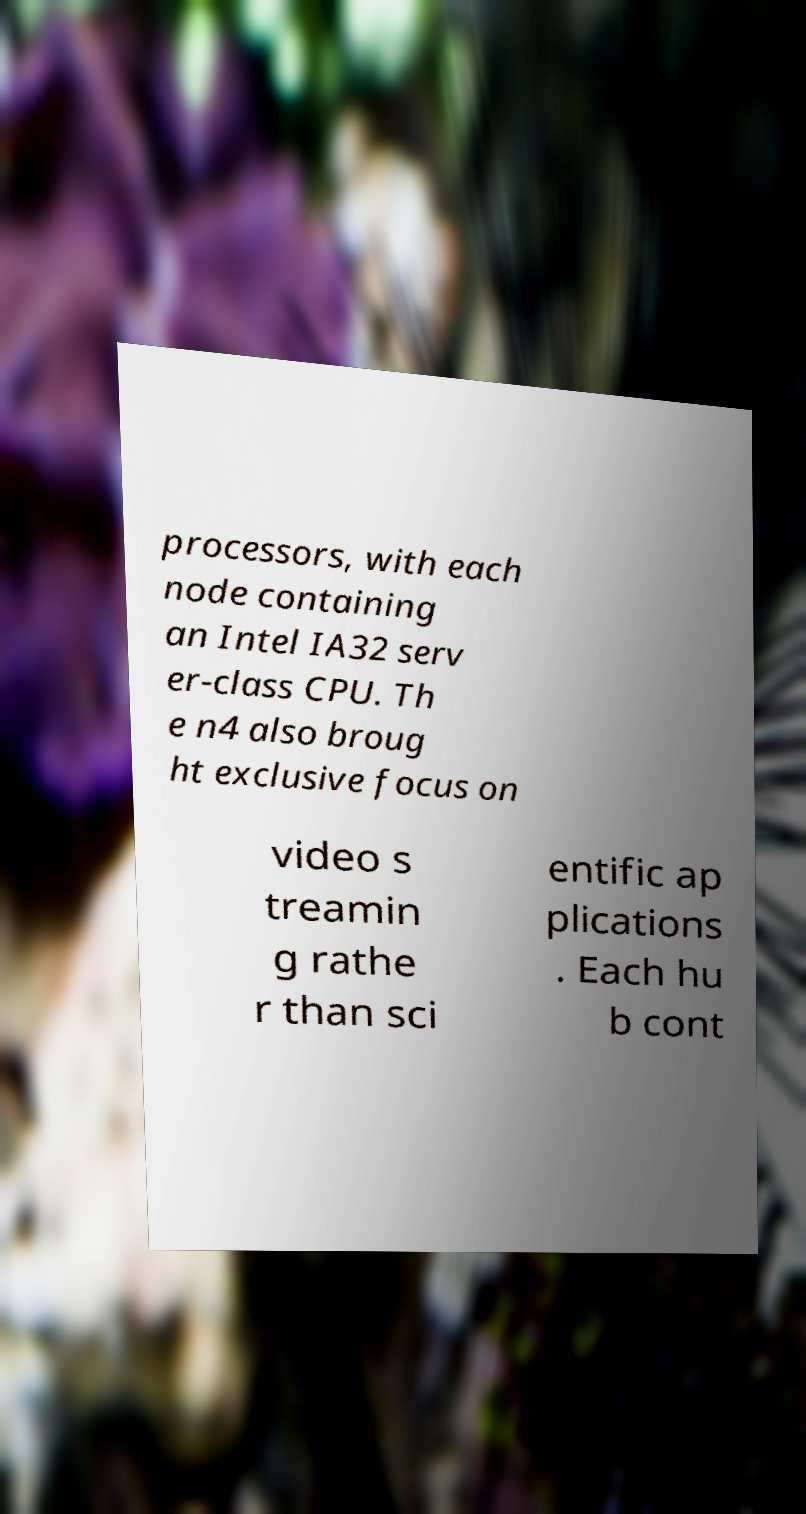Can you read and provide the text displayed in the image?This photo seems to have some interesting text. Can you extract and type it out for me? processors, with each node containing an Intel IA32 serv er-class CPU. Th e n4 also broug ht exclusive focus on video s treamin g rathe r than sci entific ap plications . Each hu b cont 